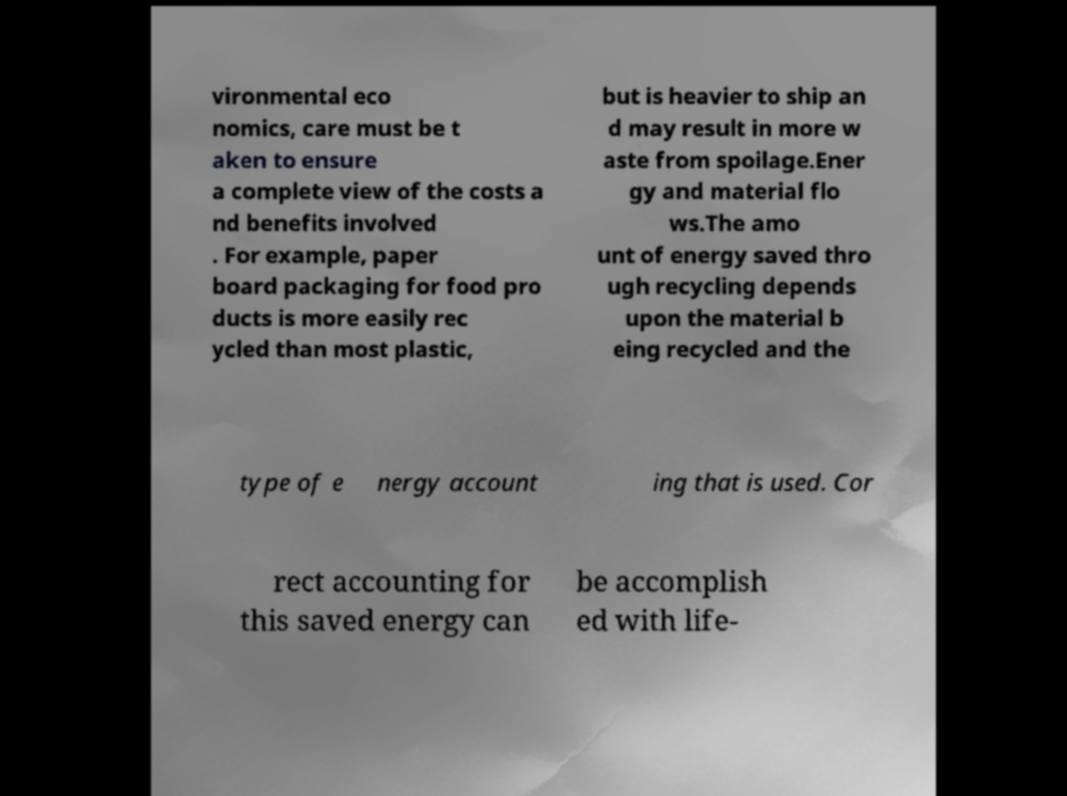Could you assist in decoding the text presented in this image and type it out clearly? vironmental eco nomics, care must be t aken to ensure a complete view of the costs a nd benefits involved . For example, paper board packaging for food pro ducts is more easily rec ycled than most plastic, but is heavier to ship an d may result in more w aste from spoilage.Ener gy and material flo ws.The amo unt of energy saved thro ugh recycling depends upon the material b eing recycled and the type of e nergy account ing that is used. Cor rect accounting for this saved energy can be accomplish ed with life- 